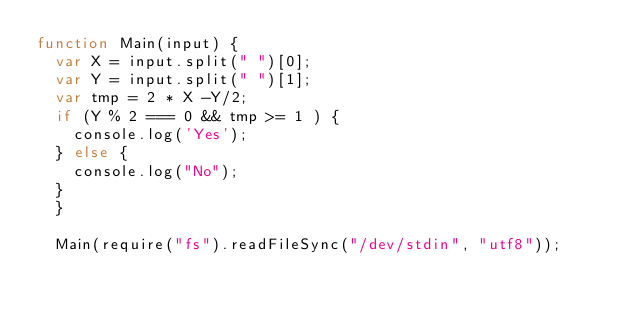<code> <loc_0><loc_0><loc_500><loc_500><_JavaScript_>function Main(input) {
  var X = input.split(" ")[0];
  var Y = input.split(" ")[1];
  var tmp = 2 * X -Y/2;
  if (Y % 2 === 0 && tmp >= 1 ) {
    console.log('Yes');
  } else {
    console.log("No");
  }
  }

  Main(require("fs").readFileSync("/dev/stdin", "utf8"));</code> 